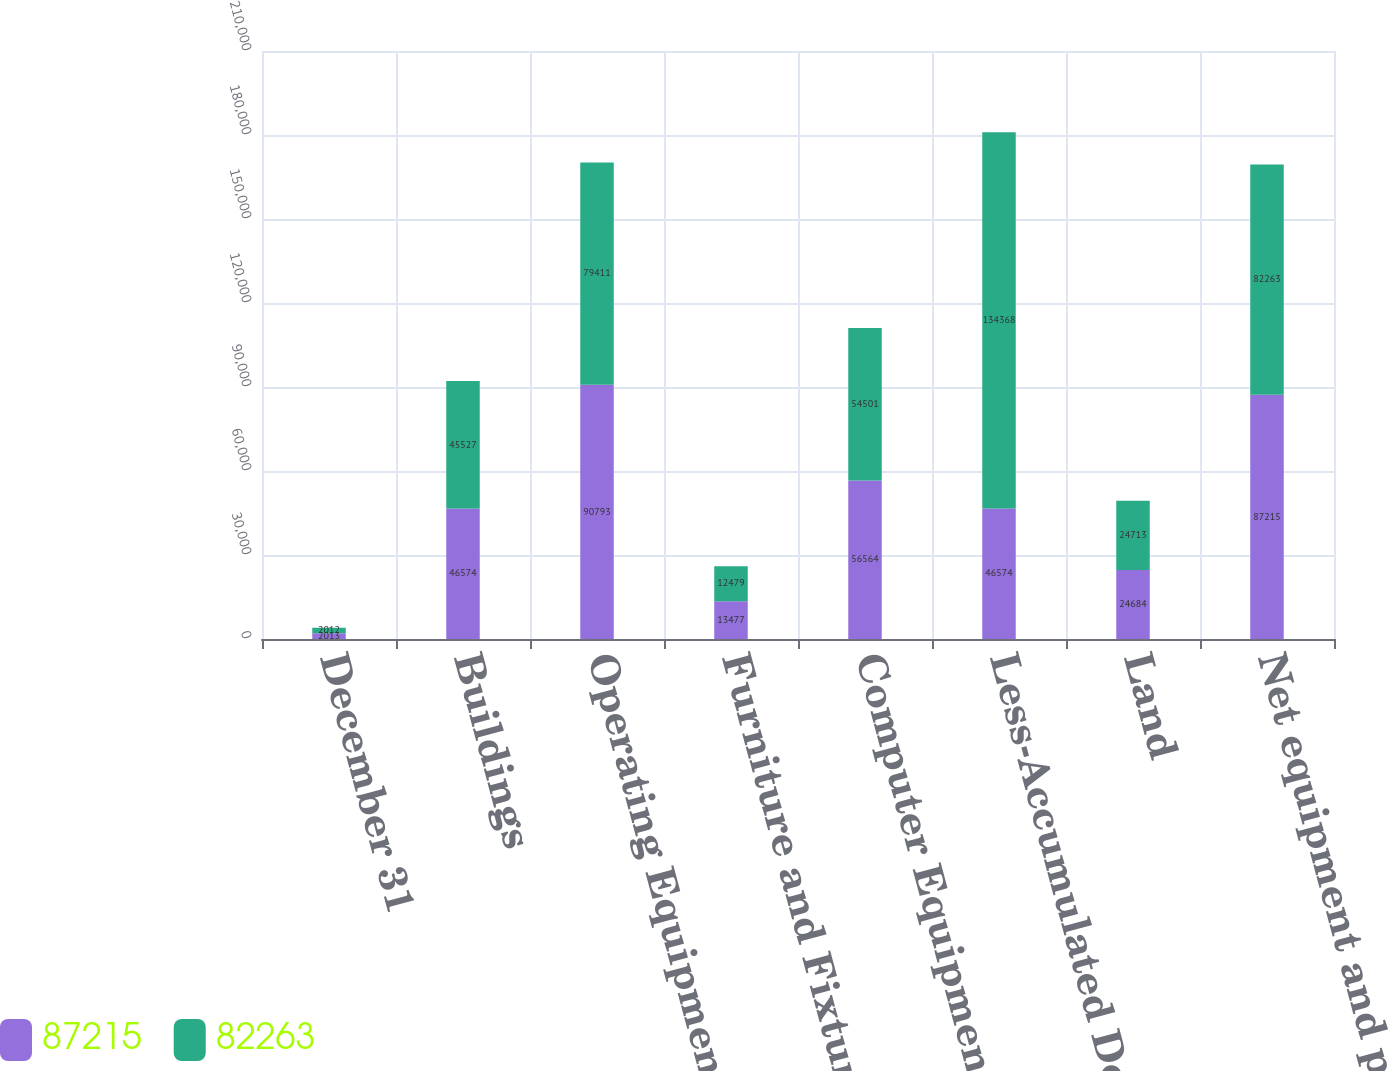Convert chart. <chart><loc_0><loc_0><loc_500><loc_500><stacked_bar_chart><ecel><fcel>December 31<fcel>Buildings<fcel>Operating Equipment<fcel>Furniture and Fixtures<fcel>Computer Equipment and Systems<fcel>Less-Accumulated Depreciation<fcel>Land<fcel>Net equipment and property<nl><fcel>87215<fcel>2013<fcel>46574<fcel>90793<fcel>13477<fcel>56564<fcel>46574<fcel>24684<fcel>87215<nl><fcel>82263<fcel>2012<fcel>45527<fcel>79411<fcel>12479<fcel>54501<fcel>134368<fcel>24713<fcel>82263<nl></chart> 